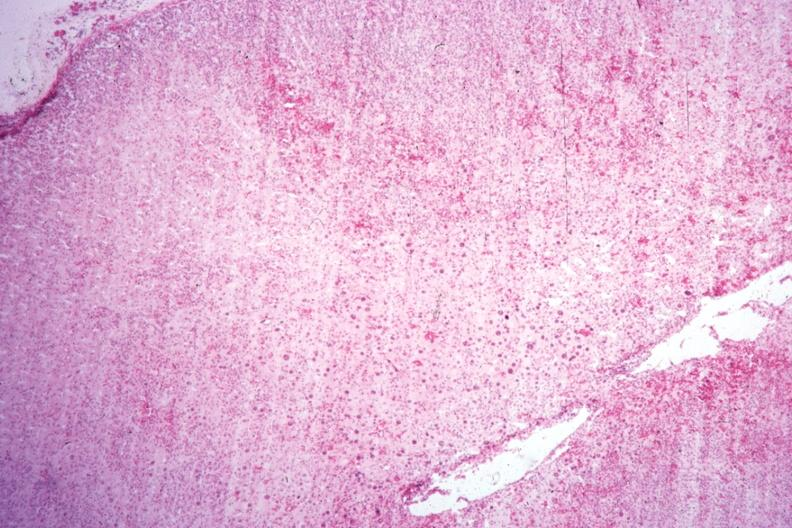where is this part in the figure?
Answer the question using a single word or phrase. Endocrine system 